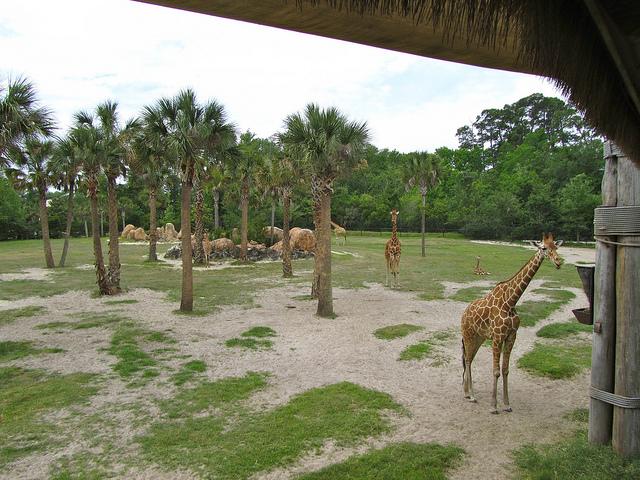What are they?
Concise answer only. Giraffes. Is it springtime?
Quick response, please. Yes. Is there a person in the picture?
Concise answer only. No. How many giraffes can you count?
Answer briefly. 3. What is the smell?
Write a very short answer. Giraffes. Do these animals live in the wild?
Short answer required. No. What animal is this?
Give a very brief answer. Giraffe. What is the giraffe in front about to do?
Answer briefly. Eat. How many bodies of water present?
Short answer required. 0. How many animals can be seen?
Be succinct. 3. Is this a winter scene?
Short answer required. No. 